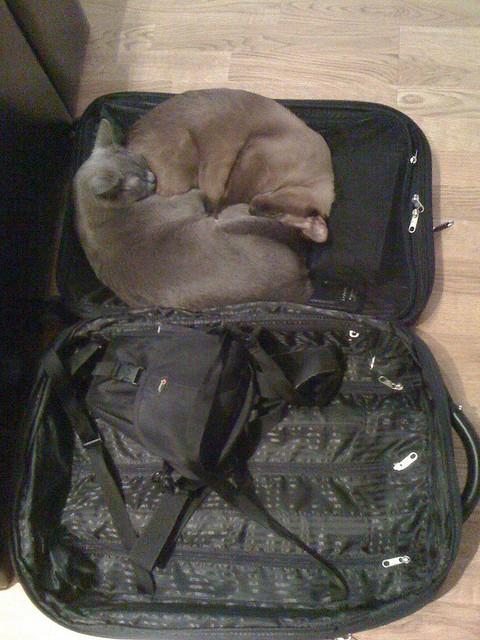What animals are pictured?
Give a very brief answer. Cats. What is the count of animals in the suitcase?
Give a very brief answer. 2. Do these animals travel in suitcases?
Write a very short answer. No. 